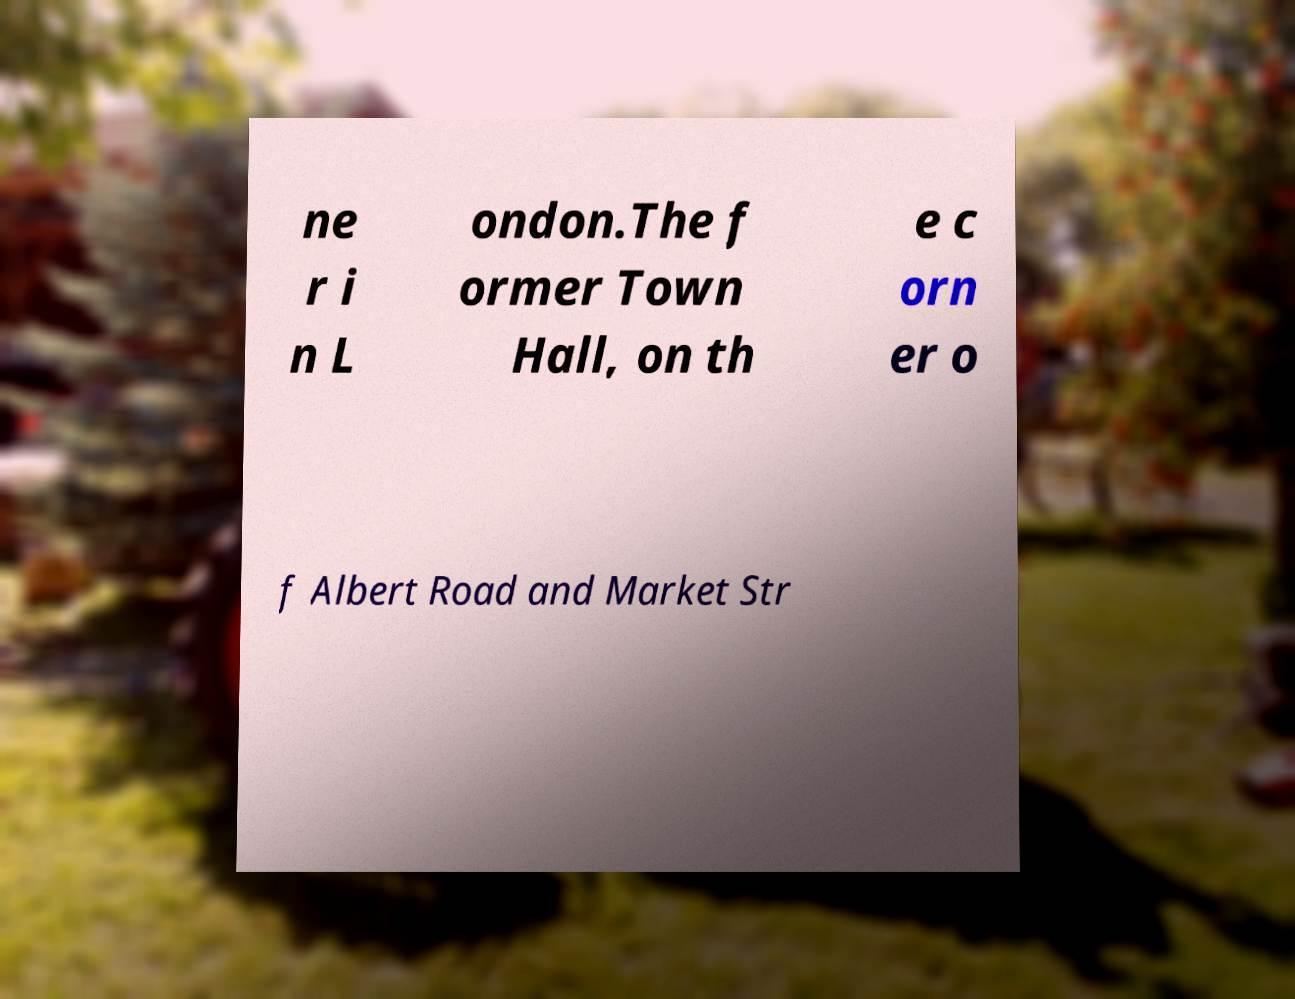Could you extract and type out the text from this image? ne r i n L ondon.The f ormer Town Hall, on th e c orn er o f Albert Road and Market Str 